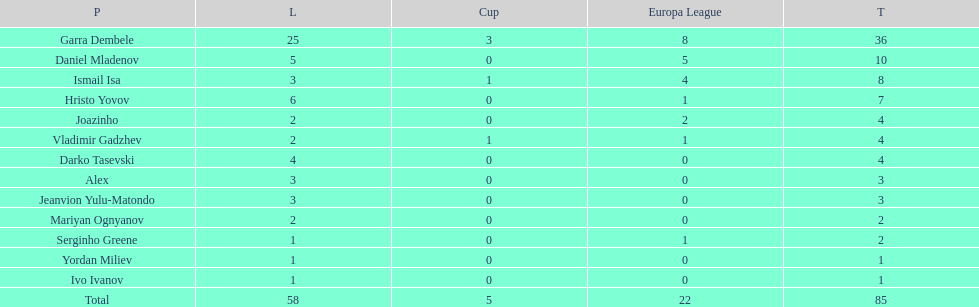Who was the top goalscorer on this team? Garra Dembele. 